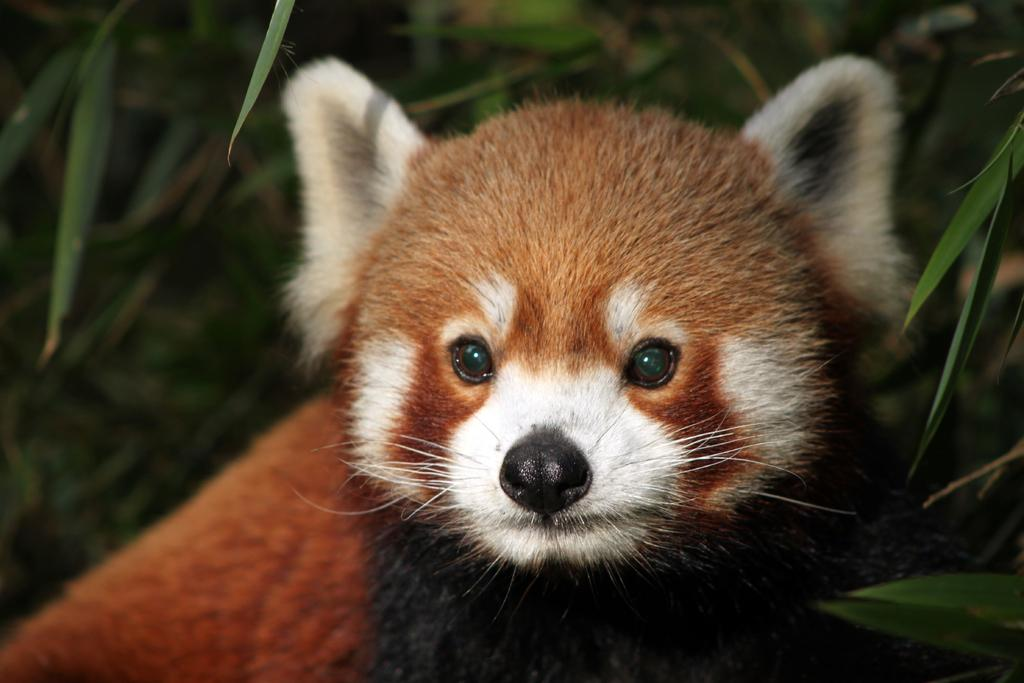What animal is present in the image? There is a fox in the image. What type of vegetation or natural elements can be seen in the image? There are leaves in the image. What type of paint is being used by the goat in the image? There is no goat or paint present in the image; it features a fox and leaves. What railway system can be seen in the image? There is no railway system present in the image. 